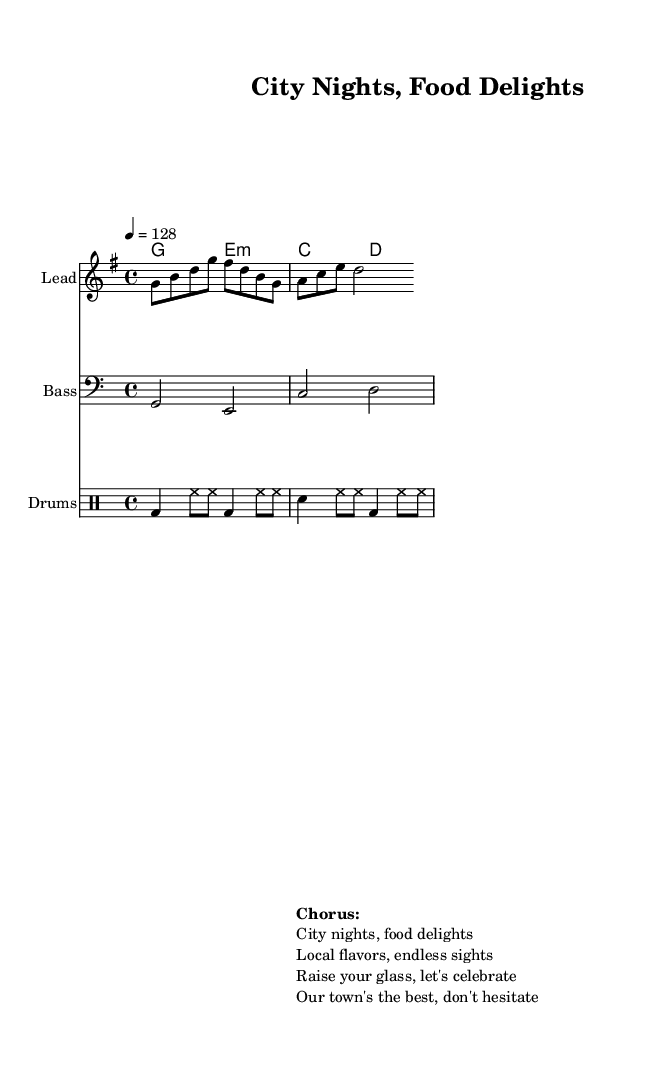What is the key signature of this music? The key signature is G major, which has one sharp (F#). It’s derived from the global settings in the score.
Answer: G major What is the time signature of this music? The time signature is 4/4, indicated in the global settings of the score. This means there are four beats in each measure, and each quarter note gets one beat.
Answer: 4/4 What is the tempo marking for this piece? The tempo marking is 128 beats per minute, specified in the global settings. This indicates a moderately fast tempo suitable for party music.
Answer: 128 How many measures are there in the melody? The melody consists of two measures. These are counted visually by examining the notation in the lead staff, with each measure separated by vertical lines.
Answer: 2 What type of drum pattern is used in this piece? The drum pattern includes bass drum, hi-hat, and snare, indicated by specific notations in the drumming staff. This combination is commonly used in hip-hop to create a solid groove.
Answer: Bass and snare What is the main theme expressed in the chorus? The main theme expressed in the chorus is celebrating local nightlife and food culture, as detailed in the lyrics provided. It emphasizes camaraderie and enjoyment within the community context.
Answer: Celebration 